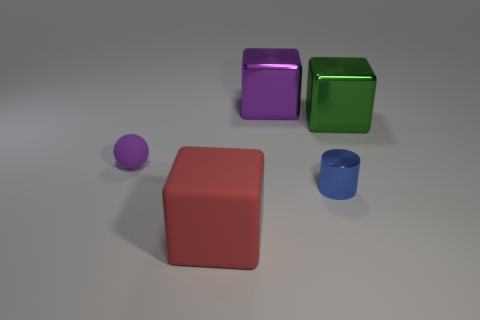Add 1 small rubber balls. How many objects exist? 6 Subtract all cylinders. How many objects are left? 4 Add 2 small purple things. How many small purple things exist? 3 Subtract 0 gray spheres. How many objects are left? 5 Subtract all purple spheres. Subtract all metallic things. How many objects are left? 1 Add 3 tiny purple balls. How many tiny purple balls are left? 4 